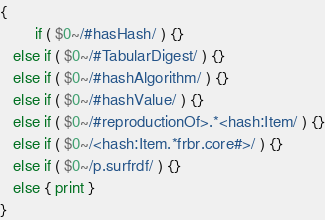Convert code to text. <code><loc_0><loc_0><loc_500><loc_500><_Awk_>{
        if ( $0~/#hasHash/ ) {}
   else if ( $0~/#TabularDigest/ ) {}
   else if ( $0~/#hashAlgorithm/ ) {}
   else if ( $0~/#hashValue/ ) {}
   else if ( $0~/#reproductionOf>.*<hash:Item/ ) {}
   else if ( $0~/<hash:Item.*frbr.core#>/ ) {}
   else if ( $0~/p.surfrdf/ ) {}
   else { print }
}
</code> 